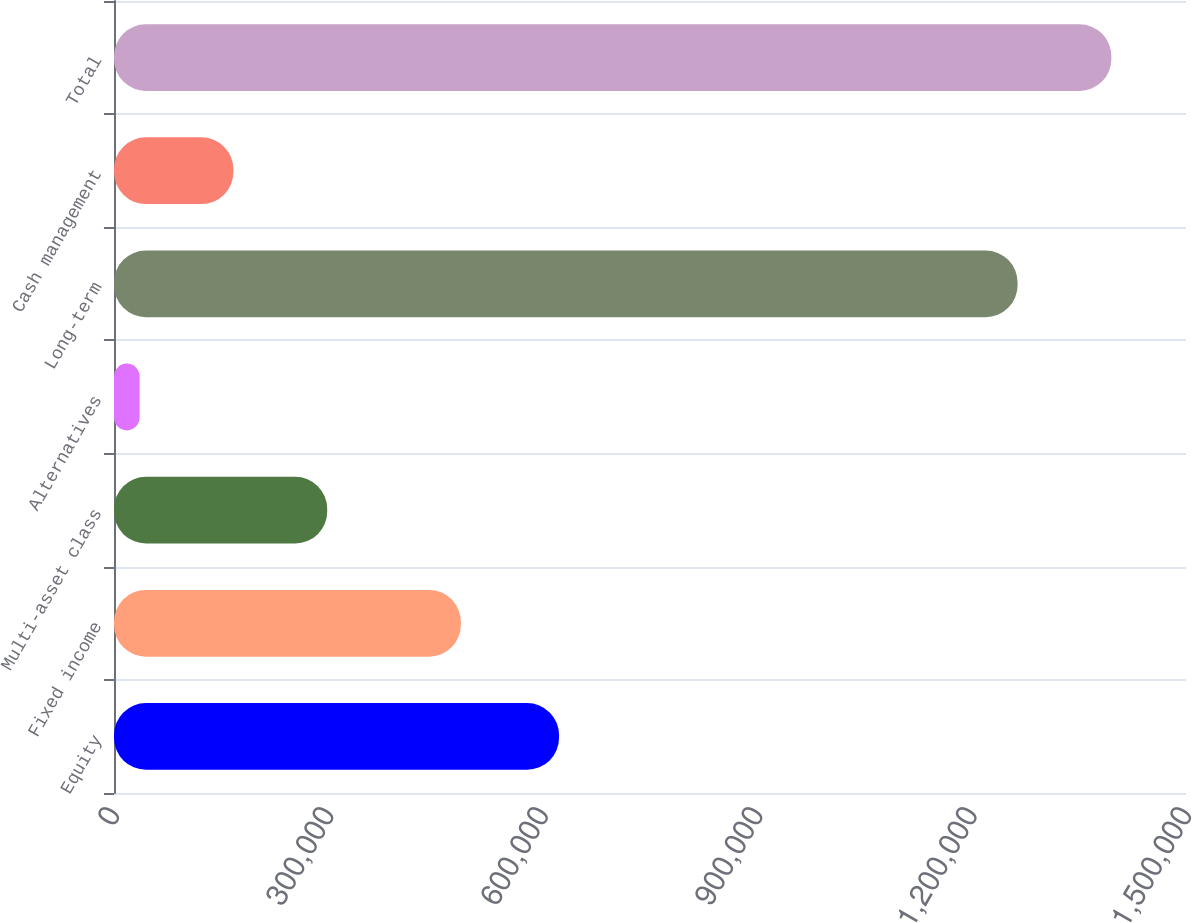<chart> <loc_0><loc_0><loc_500><loc_500><bar_chart><fcel>Equity<fcel>Fixed income<fcel>Multi-asset class<fcel>Alternatives<fcel>Long-term<fcel>Cash management<fcel>Total<nl><fcel>622744<fcel>485388<fcel>298316<fcel>35855<fcel>1.26435e+06<fcel>167086<fcel>1.39558e+06<nl></chart> 